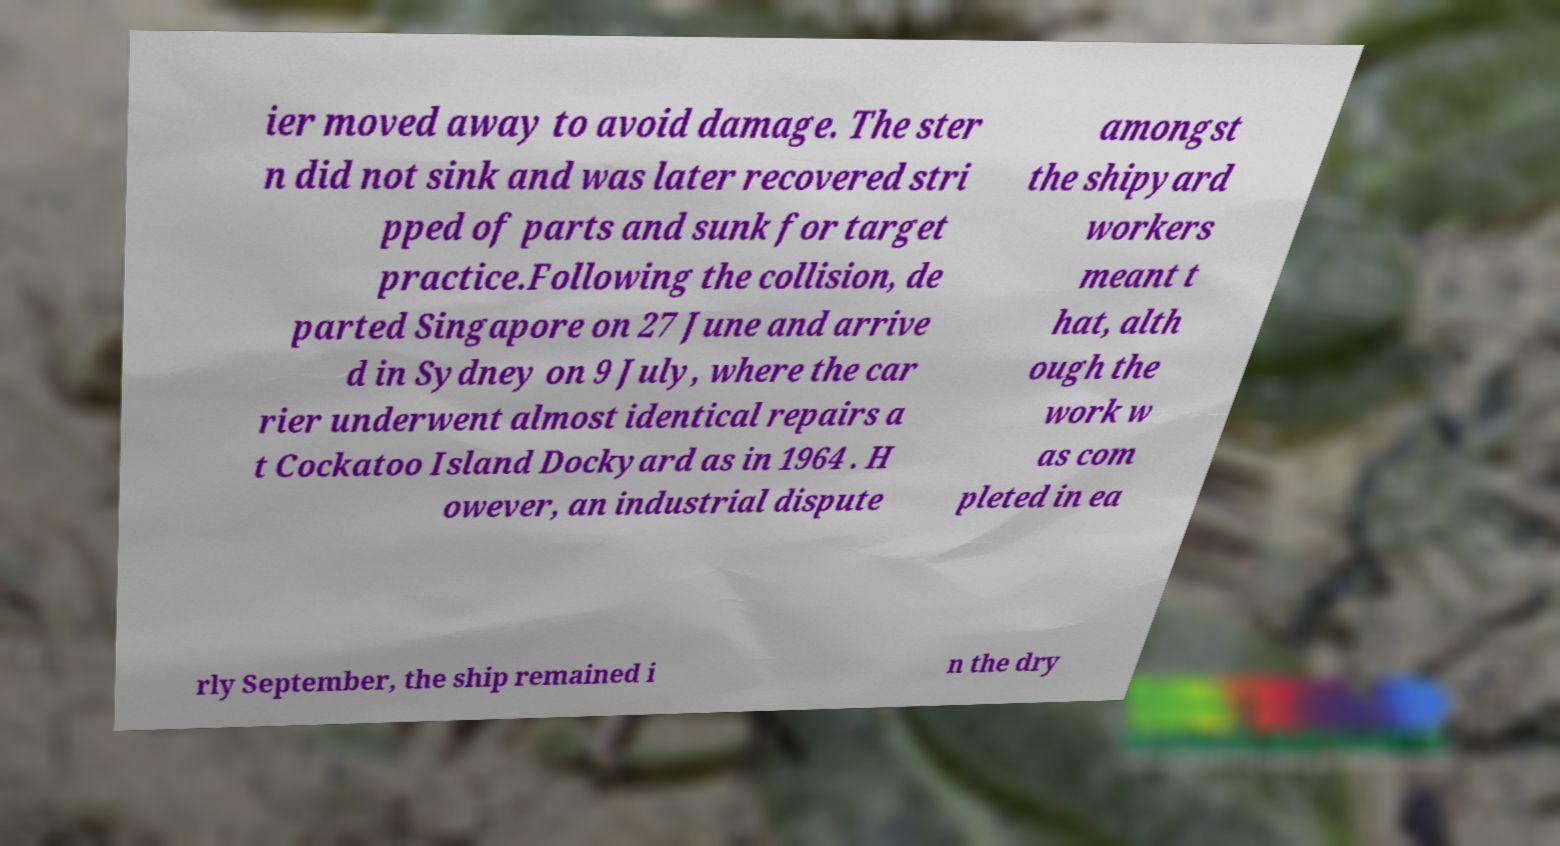Can you accurately transcribe the text from the provided image for me? ier moved away to avoid damage. The ster n did not sink and was later recovered stri pped of parts and sunk for target practice.Following the collision, de parted Singapore on 27 June and arrive d in Sydney on 9 July, where the car rier underwent almost identical repairs a t Cockatoo Island Dockyard as in 1964 . H owever, an industrial dispute amongst the shipyard workers meant t hat, alth ough the work w as com pleted in ea rly September, the ship remained i n the dry 